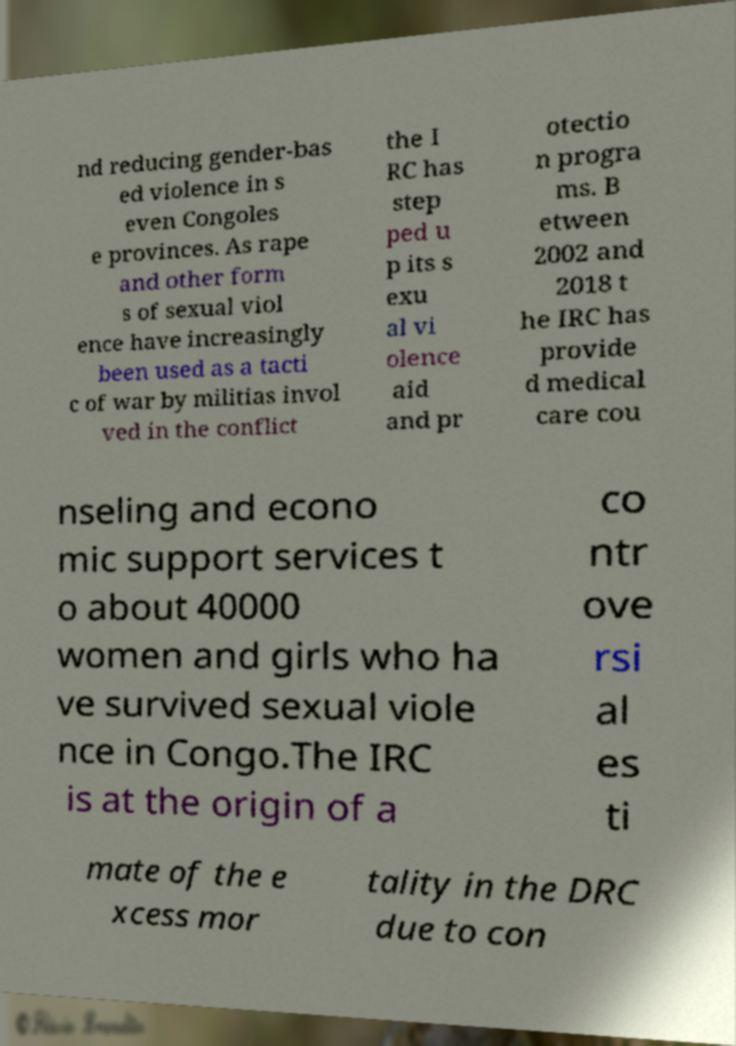I need the written content from this picture converted into text. Can you do that? nd reducing gender-bas ed violence in s even Congoles e provinces. As rape and other form s of sexual viol ence have increasingly been used as a tacti c of war by militias invol ved in the conflict the I RC has step ped u p its s exu al vi olence aid and pr otectio n progra ms. B etween 2002 and 2018 t he IRC has provide d medical care cou nseling and econo mic support services t o about 40000 women and girls who ha ve survived sexual viole nce in Congo.The IRC is at the origin of a co ntr ove rsi al es ti mate of the e xcess mor tality in the DRC due to con 